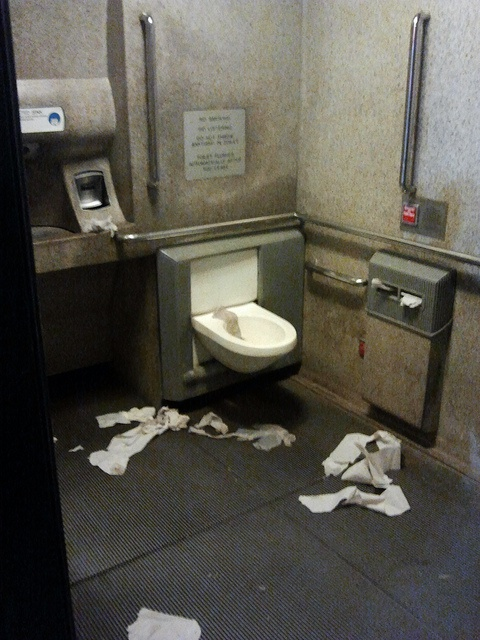Describe the objects in this image and their specific colors. I can see a toilet in black, darkgreen, beige, and gray tones in this image. 